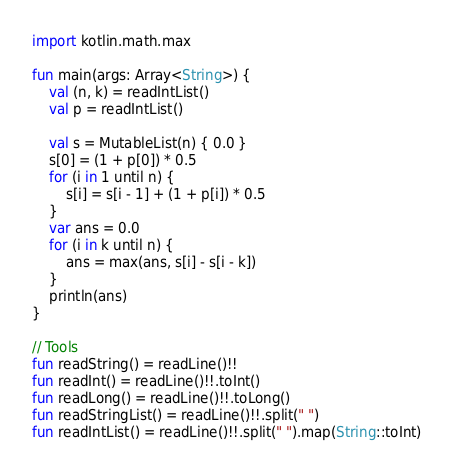Convert code to text. <code><loc_0><loc_0><loc_500><loc_500><_Kotlin_>import kotlin.math.max

fun main(args: Array<String>) {
    val (n, k) = readIntList()
    val p = readIntList()

    val s = MutableList(n) { 0.0 }
    s[0] = (1 + p[0]) * 0.5
    for (i in 1 until n) {
        s[i] = s[i - 1] + (1 + p[i]) * 0.5
    }
    var ans = 0.0
    for (i in k until n) {
        ans = max(ans, s[i] - s[i - k])
    }
    println(ans)
}

// Tools
fun readString() = readLine()!!
fun readInt() = readLine()!!.toInt()
fun readLong() = readLine()!!.toLong()
fun readStringList() = readLine()!!.split(" ")
fun readIntList() = readLine()!!.split(" ").map(String::toInt)</code> 